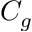<formula> <loc_0><loc_0><loc_500><loc_500>C _ { g }</formula> 